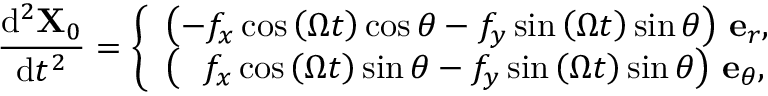<formula> <loc_0><loc_0><loc_500><loc_500>\frac { d ^ { 2 } X _ { 0 } } { d t ^ { 2 } } = \left \{ \begin{array} { l l } { \left ( - f _ { x } \cos { \left ( \Omega t \right ) } \cos \theta - f _ { y } \sin { \left ( \Omega t \right ) } \sin \theta \right ) \, e _ { r } , } \\ { \left ( \, f _ { x } \cos { \left ( \Omega t \right ) } \sin \theta - f _ { y } \sin { \left ( \Omega t \right ) } \sin \theta \right ) \, e _ { \theta } , } \end{array}</formula> 